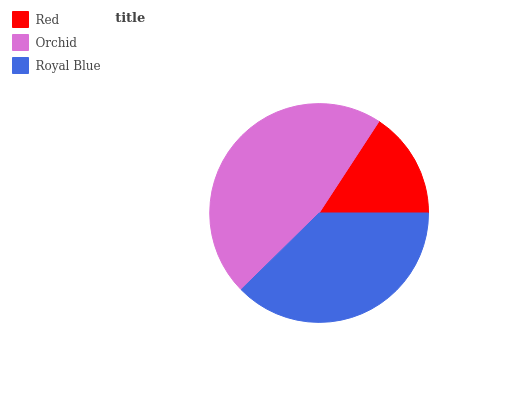Is Red the minimum?
Answer yes or no. Yes. Is Orchid the maximum?
Answer yes or no. Yes. Is Royal Blue the minimum?
Answer yes or no. No. Is Royal Blue the maximum?
Answer yes or no. No. Is Orchid greater than Royal Blue?
Answer yes or no. Yes. Is Royal Blue less than Orchid?
Answer yes or no. Yes. Is Royal Blue greater than Orchid?
Answer yes or no. No. Is Orchid less than Royal Blue?
Answer yes or no. No. Is Royal Blue the high median?
Answer yes or no. Yes. Is Royal Blue the low median?
Answer yes or no. Yes. Is Orchid the high median?
Answer yes or no. No. Is Orchid the low median?
Answer yes or no. No. 